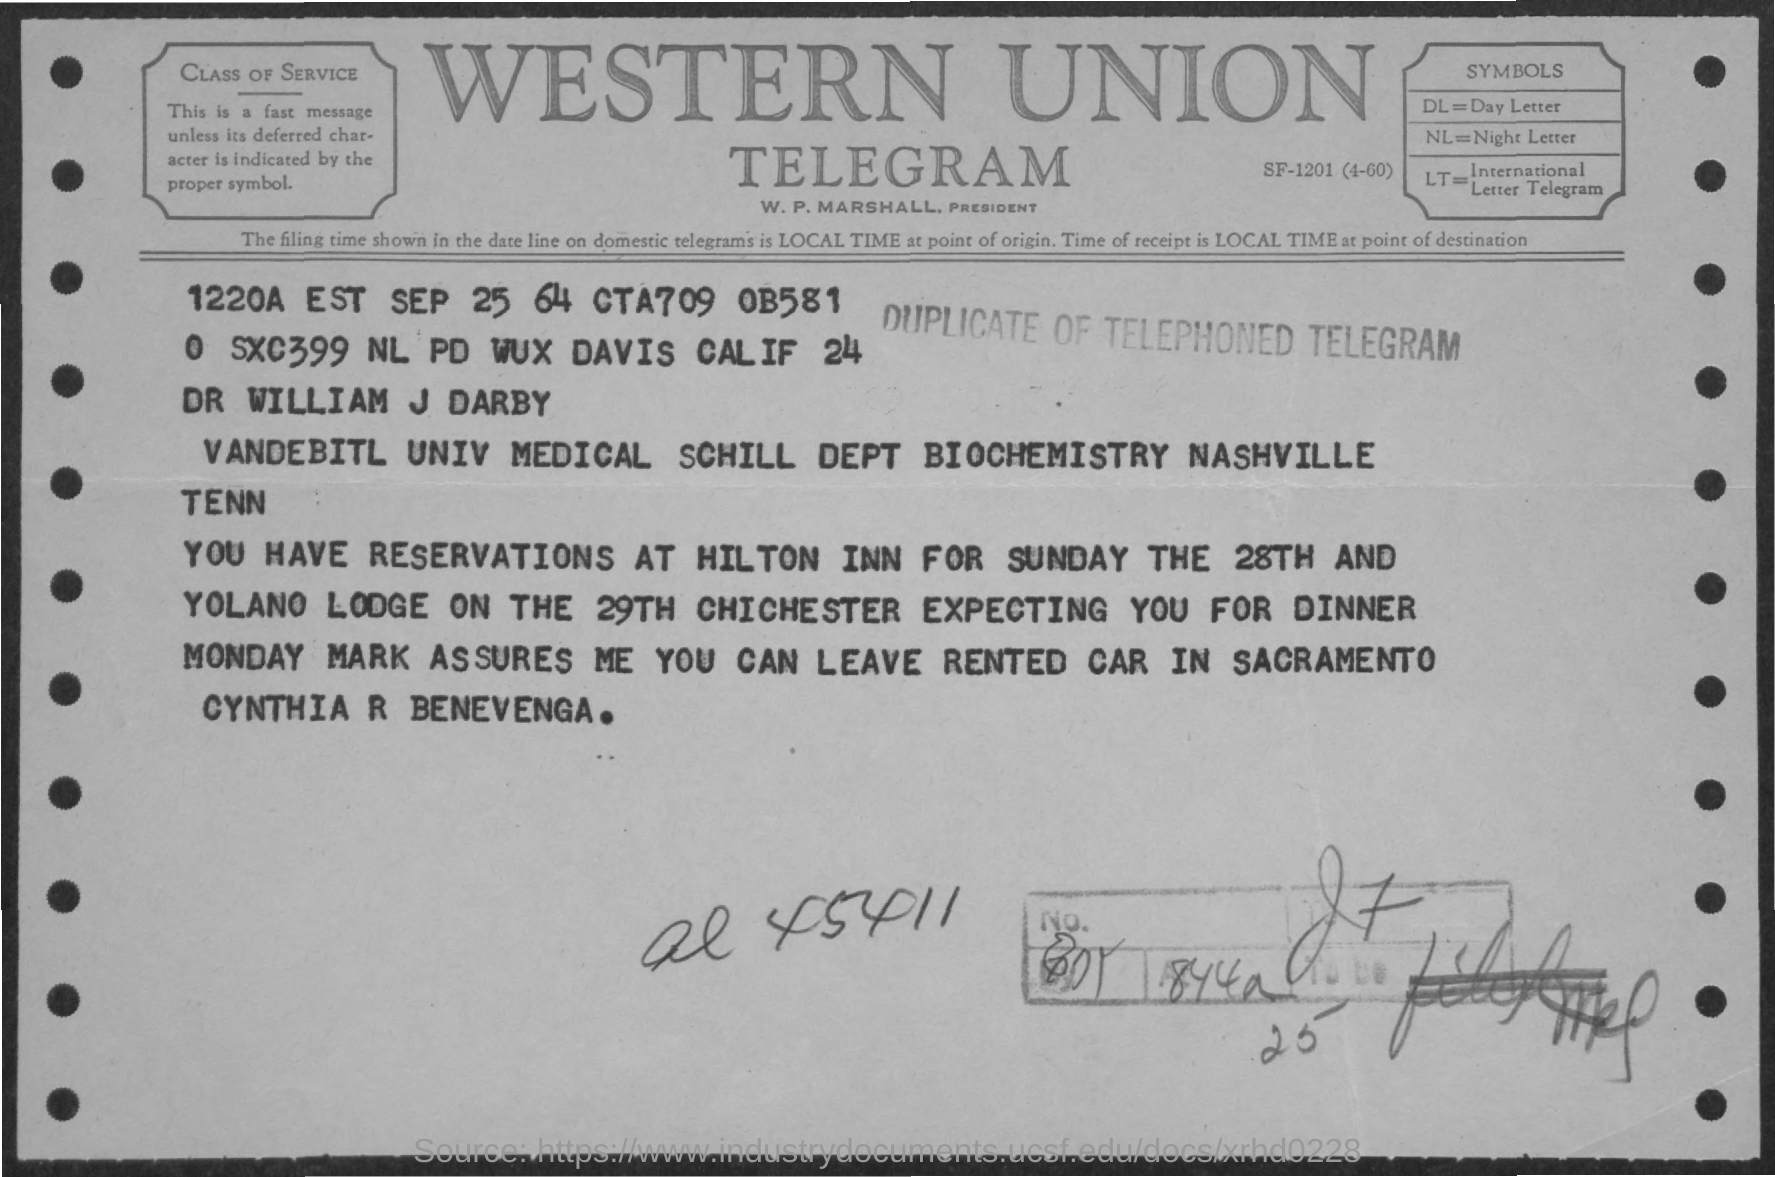Draw attention to some important aspects in this diagram. The name mentioned is DR WILLIAM J DARBY. 